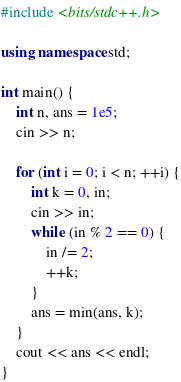Convert code to text. <code><loc_0><loc_0><loc_500><loc_500><_C++_>#include <bits/stdc++.h>

using namespace std;

int main() {
    int n, ans = 1e5;
    cin >> n;

    for (int i = 0; i < n; ++i) {
        int k = 0, in;
        cin >> in;
        while (in % 2 == 0) {
            in /= 2;
            ++k;
        }
        ans = min(ans, k);
    }
    cout << ans << endl;
}
</code> 